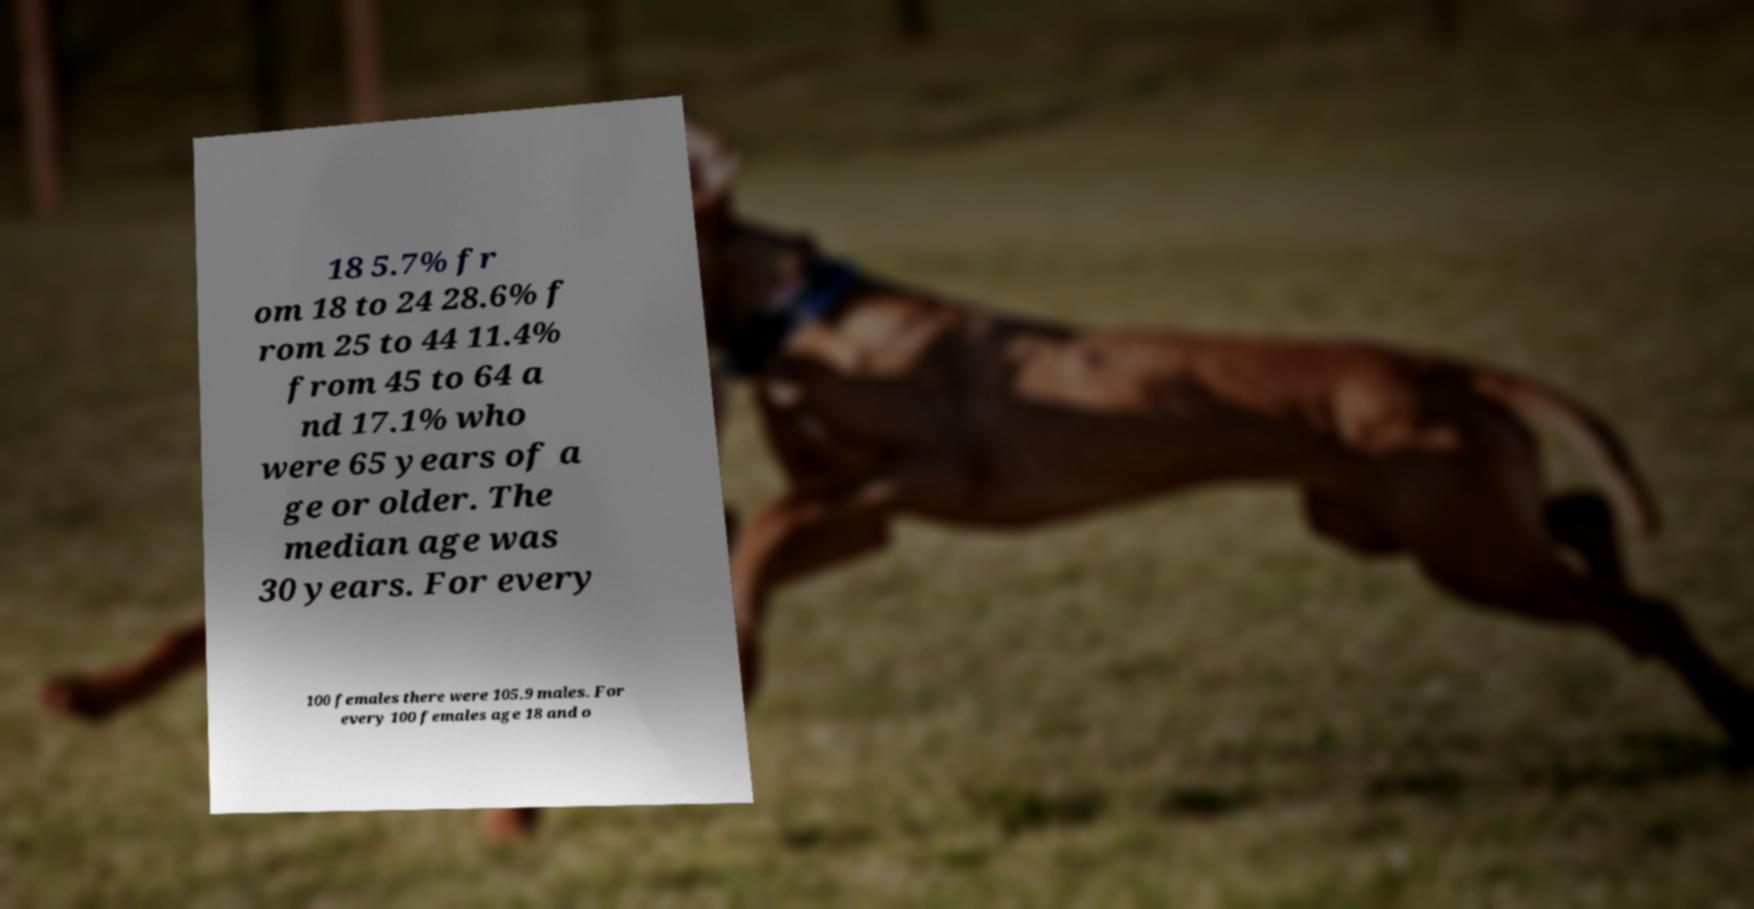Could you extract and type out the text from this image? 18 5.7% fr om 18 to 24 28.6% f rom 25 to 44 11.4% from 45 to 64 a nd 17.1% who were 65 years of a ge or older. The median age was 30 years. For every 100 females there were 105.9 males. For every 100 females age 18 and o 